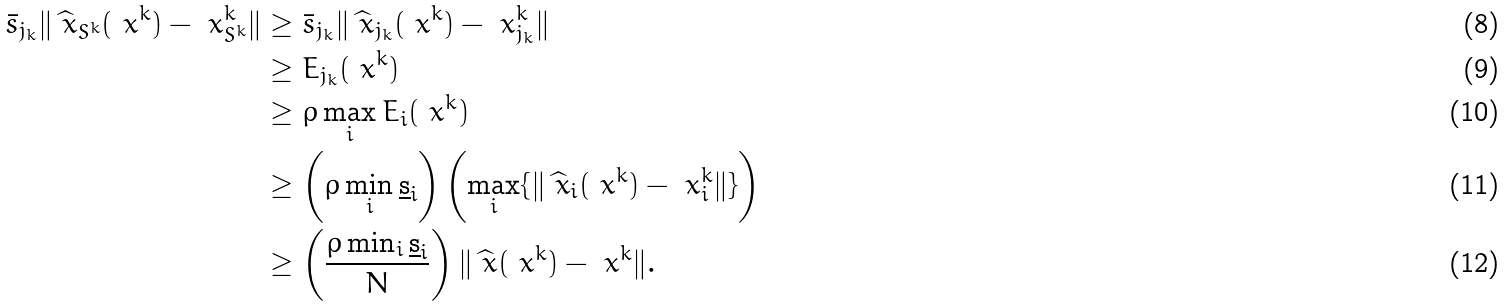Convert formula to latex. <formula><loc_0><loc_0><loc_500><loc_500>\bar { s } _ { j _ { k } } \| \widehat { \ x } _ { S ^ { k } } ( \ x ^ { k } ) - \ x ^ { k } _ { S ^ { k } } \| & \geq \bar { s } _ { j _ { k } } \| \widehat { \ x } _ { j _ { k } } ( \ x ^ { k } ) - \ x ^ { k } _ { j _ { k } } \| \\ & \geq E _ { j _ { k } } ( \ x ^ { k } ) \\ & \geq \rho \max _ { i } E _ { i } ( \ x ^ { k } ) \\ & \geq \left ( \rho \min _ { i } \underbar s _ { i } \right ) \left ( \max _ { i } \{ \| \widehat { \ x } _ { i } ( \ x ^ { k } ) - \ x ^ { k } _ { i } \| \} \right ) \\ & \geq \left ( \frac { \rho \min _ { i } \underbar s _ { i } } { N } \right ) \| \widehat { \ x } ( \ x ^ { k } ) - \ x ^ { k } \| .</formula> 